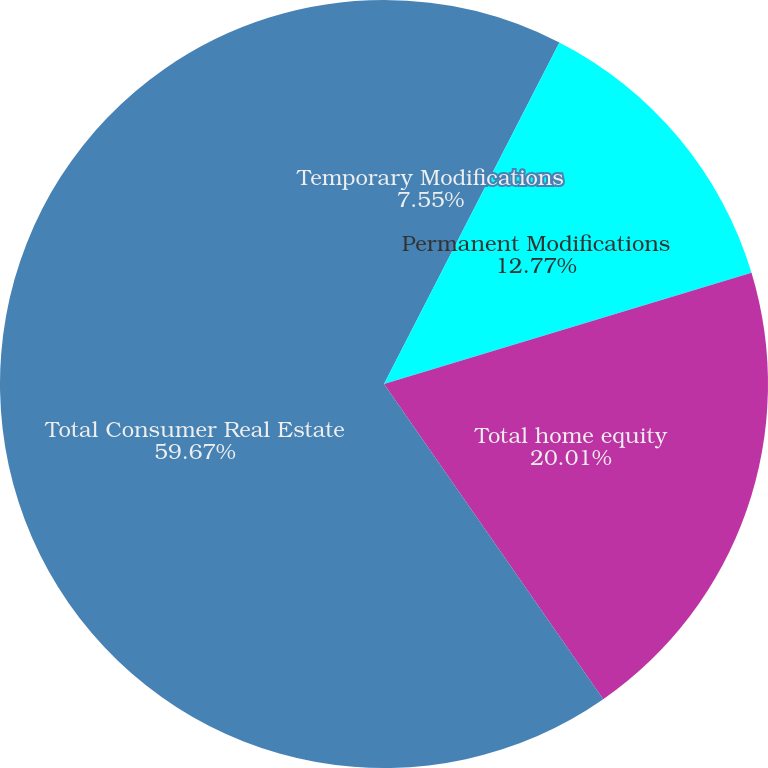Convert chart to OTSL. <chart><loc_0><loc_0><loc_500><loc_500><pie_chart><fcel>Temporary Modifications<fcel>Permanent Modifications<fcel>Total home equity<fcel>Total Consumer Real Estate<nl><fcel>7.55%<fcel>12.77%<fcel>20.01%<fcel>59.67%<nl></chart> 